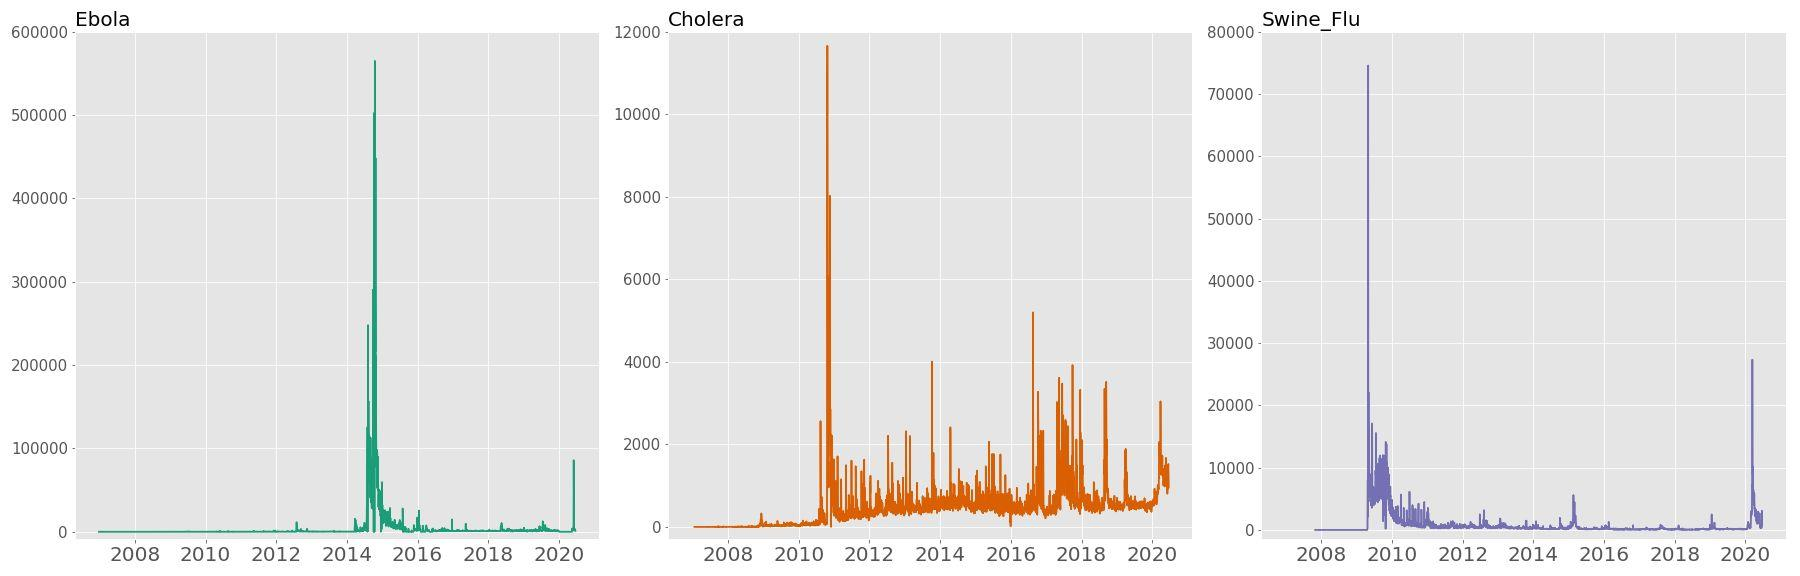Which range of years shows the most variation in search frequency for Ebola? A) 2008 - 2010 B) 2010 - 2012 C) 2012 - 2014 D) 2016 - 2018 ## For Cholera Figure: The range of years 2012 - 2014 shows the most variation, with the graph ranging from very low to extremely high values, peaking in 2014. Therefore, the correct answer is C) 2012 - 2014. 